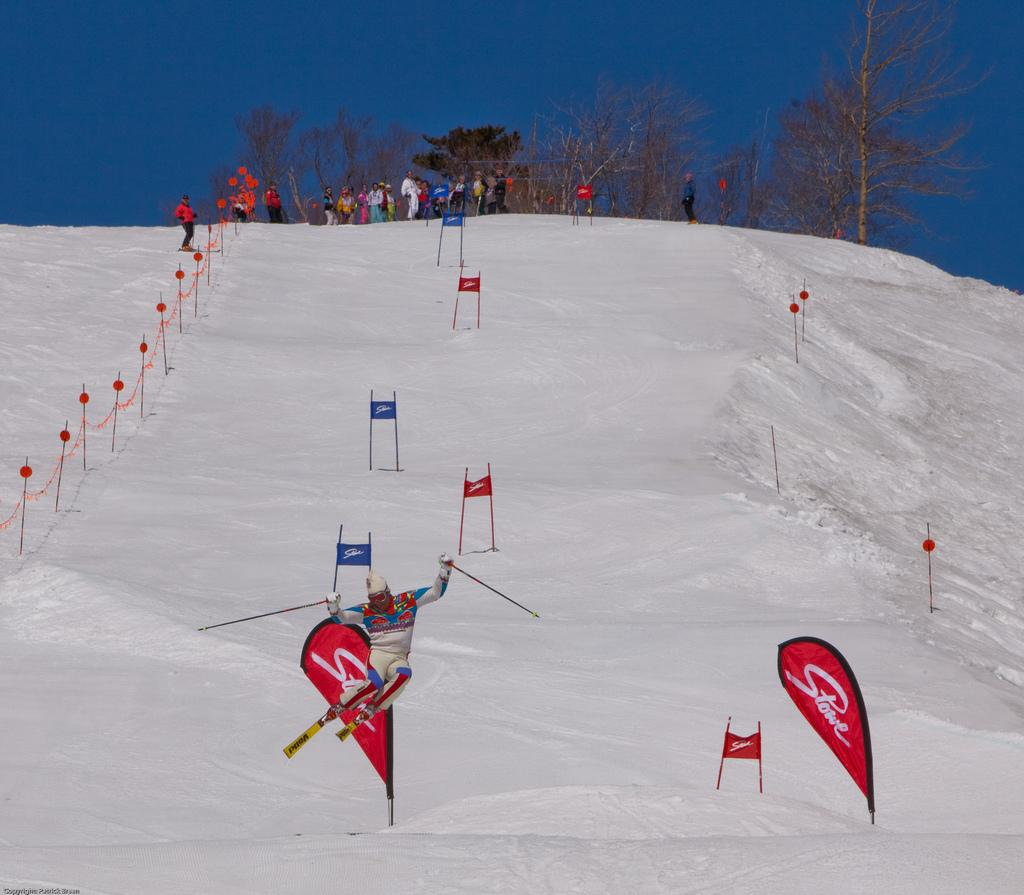Provide a one-sentence caption for the provided image. Skiers skiing, and some spectating, at a Stowe ski mountain location. 